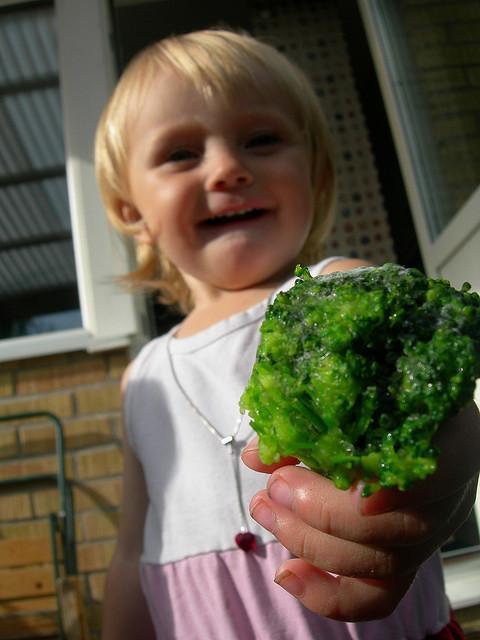How many cups on the table are wine glasses?
Give a very brief answer. 0. 